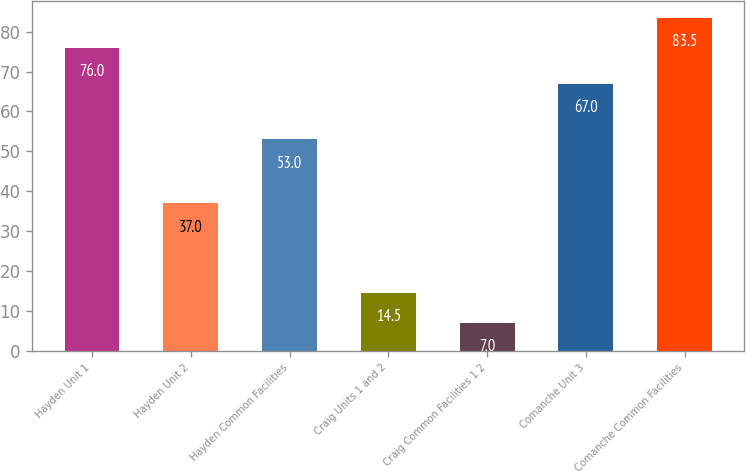Convert chart to OTSL. <chart><loc_0><loc_0><loc_500><loc_500><bar_chart><fcel>Hayden Unit 1<fcel>Hayden Unit 2<fcel>Hayden Common Facilities<fcel>Craig Units 1 and 2<fcel>Craig Common Facilities 1 2<fcel>Comanche Unit 3<fcel>Comanche Common Facilities<nl><fcel>76<fcel>37<fcel>53<fcel>14.5<fcel>7<fcel>67<fcel>83.5<nl></chart> 